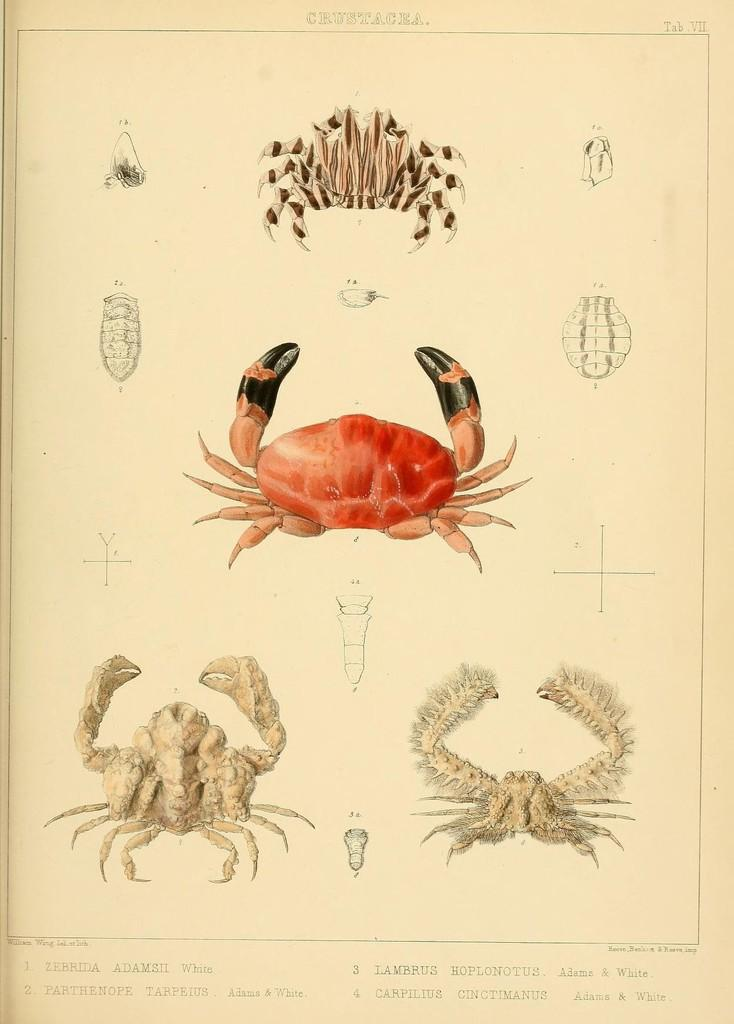What is depicted in the paintings in the image? There are paintings of four crabs in the image. Is there any text accompanying the paintings? Yes, there is text in the image. What might be the source of the image? The image may be taken from a book. How many birds are flying down the slope in the image? There are no birds or slopes present in the image; it features paintings of four crabs and accompanying text. 